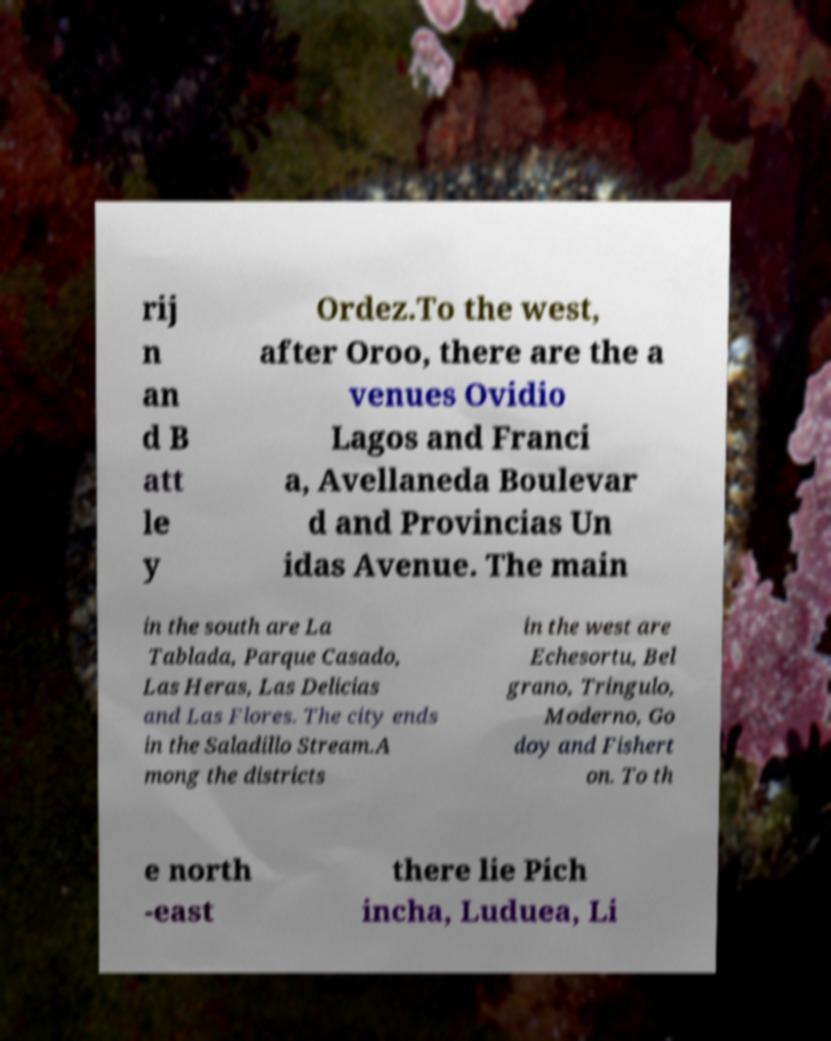I need the written content from this picture converted into text. Can you do that? rij n an d B att le y Ordez.To the west, after Oroo, there are the a venues Ovidio Lagos and Franci a, Avellaneda Boulevar d and Provincias Un idas Avenue. The main in the south are La Tablada, Parque Casado, Las Heras, Las Delicias and Las Flores. The city ends in the Saladillo Stream.A mong the districts in the west are Echesortu, Bel grano, Tringulo, Moderno, Go doy and Fishert on. To th e north -east there lie Pich incha, Luduea, Li 